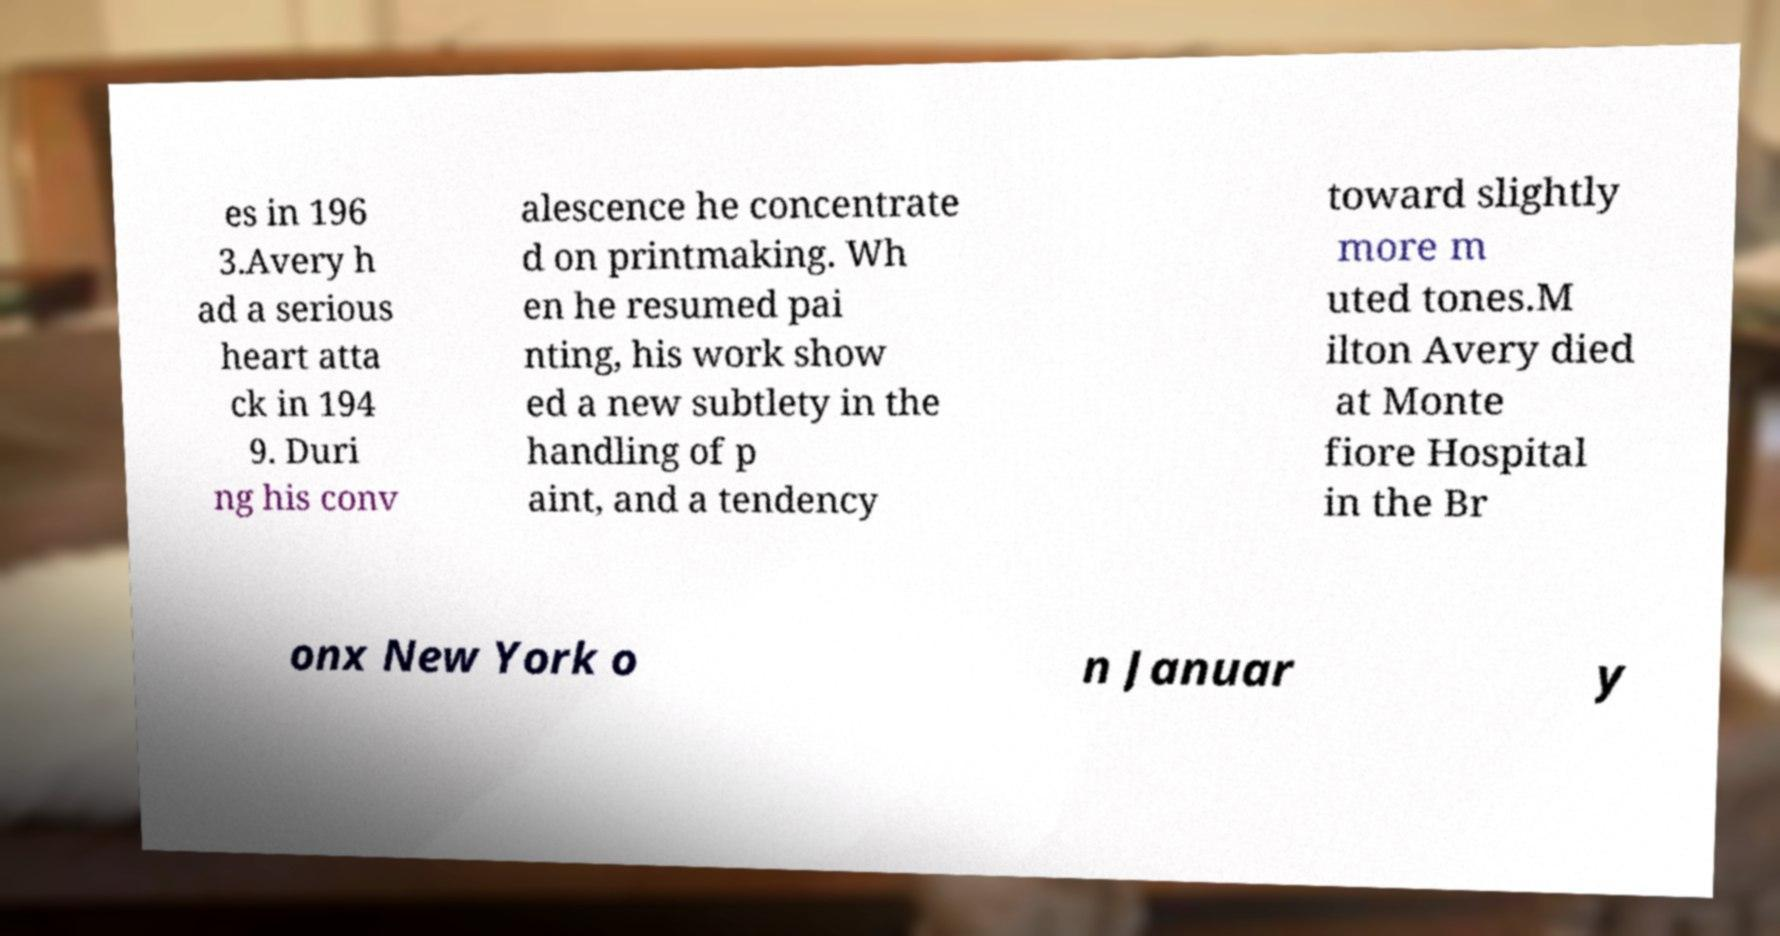I need the written content from this picture converted into text. Can you do that? es in 196 3.Avery h ad a serious heart atta ck in 194 9. Duri ng his conv alescence he concentrate d on printmaking. Wh en he resumed pai nting, his work show ed a new subtlety in the handling of p aint, and a tendency toward slightly more m uted tones.M ilton Avery died at Monte fiore Hospital in the Br onx New York o n Januar y 